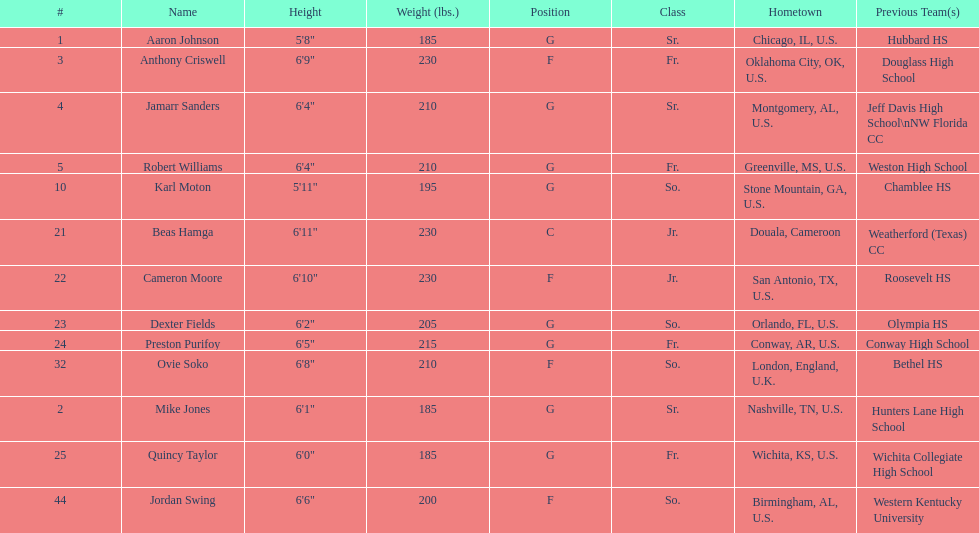Besides soko, mention a player who is not american. Beas Hamga. 